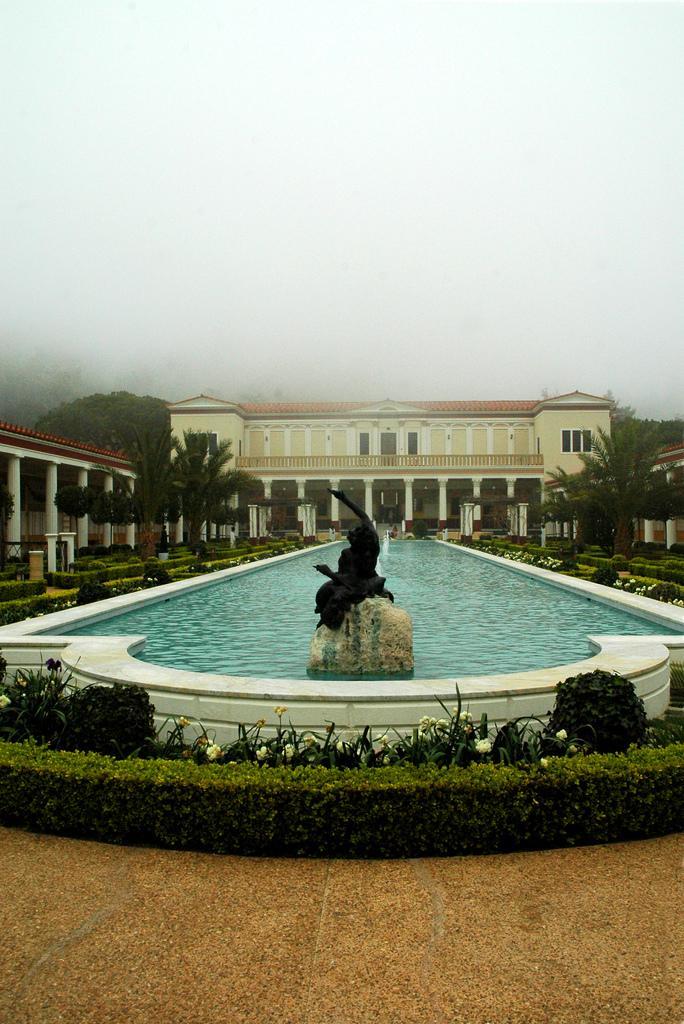Can you describe this image briefly? In the center of the image there is a building. At the bottom we can see hedge, shrubs, statue and a fountain. In the background there are trees and sky. 